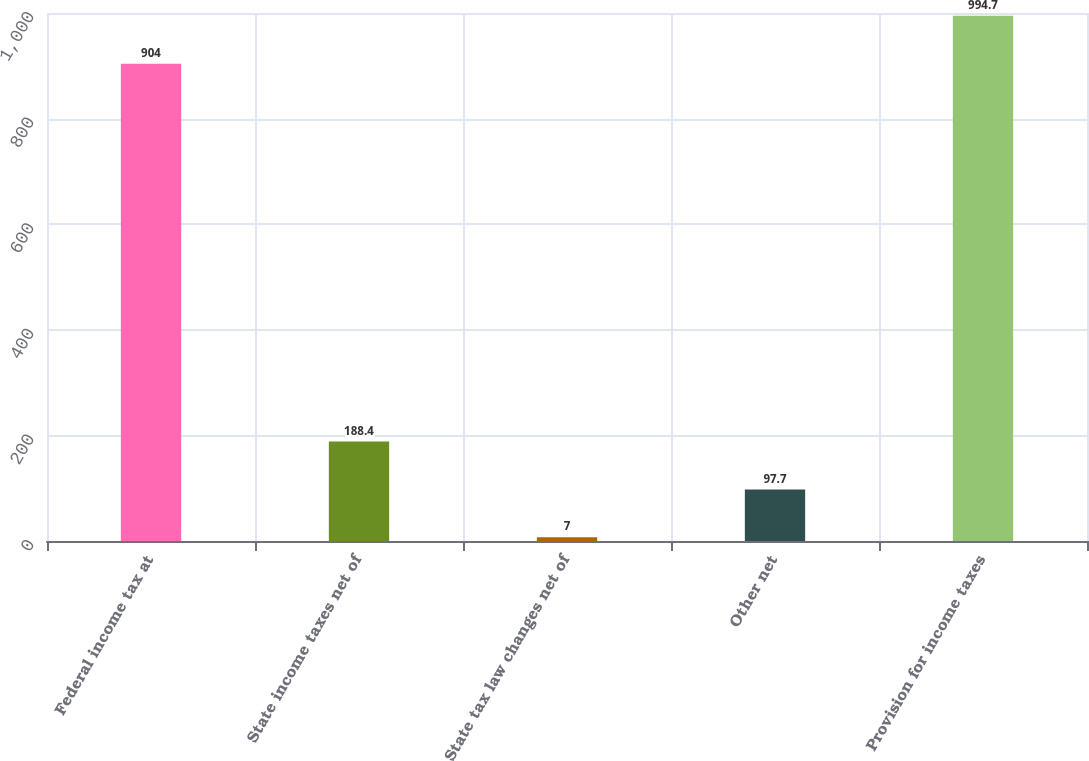<chart> <loc_0><loc_0><loc_500><loc_500><bar_chart><fcel>Federal income tax at<fcel>State income taxes net of<fcel>State tax law changes net of<fcel>Other net<fcel>Provision for income taxes<nl><fcel>904<fcel>188.4<fcel>7<fcel>97.7<fcel>994.7<nl></chart> 